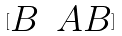Convert formula to latex. <formula><loc_0><loc_0><loc_500><loc_500>[ \begin{matrix} B & A B \end{matrix} ]</formula> 